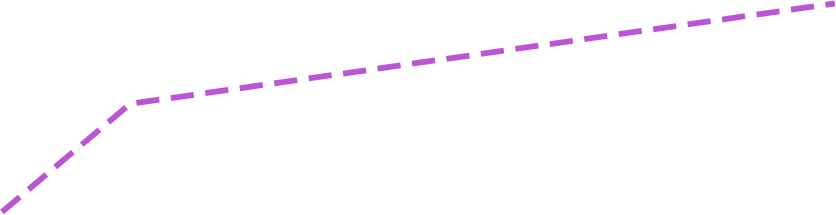<chart> <loc_0><loc_0><loc_500><loc_500><line_chart><ecel><fcel>$ 45,158<nl><fcel>1748.06<fcel>36354.8<nl><fcel>1800.22<fcel>41983.9<nl><fcel>2087.44<fcel>47216.6<nl><fcel>2269.68<fcel>50896.4<nl></chart> 